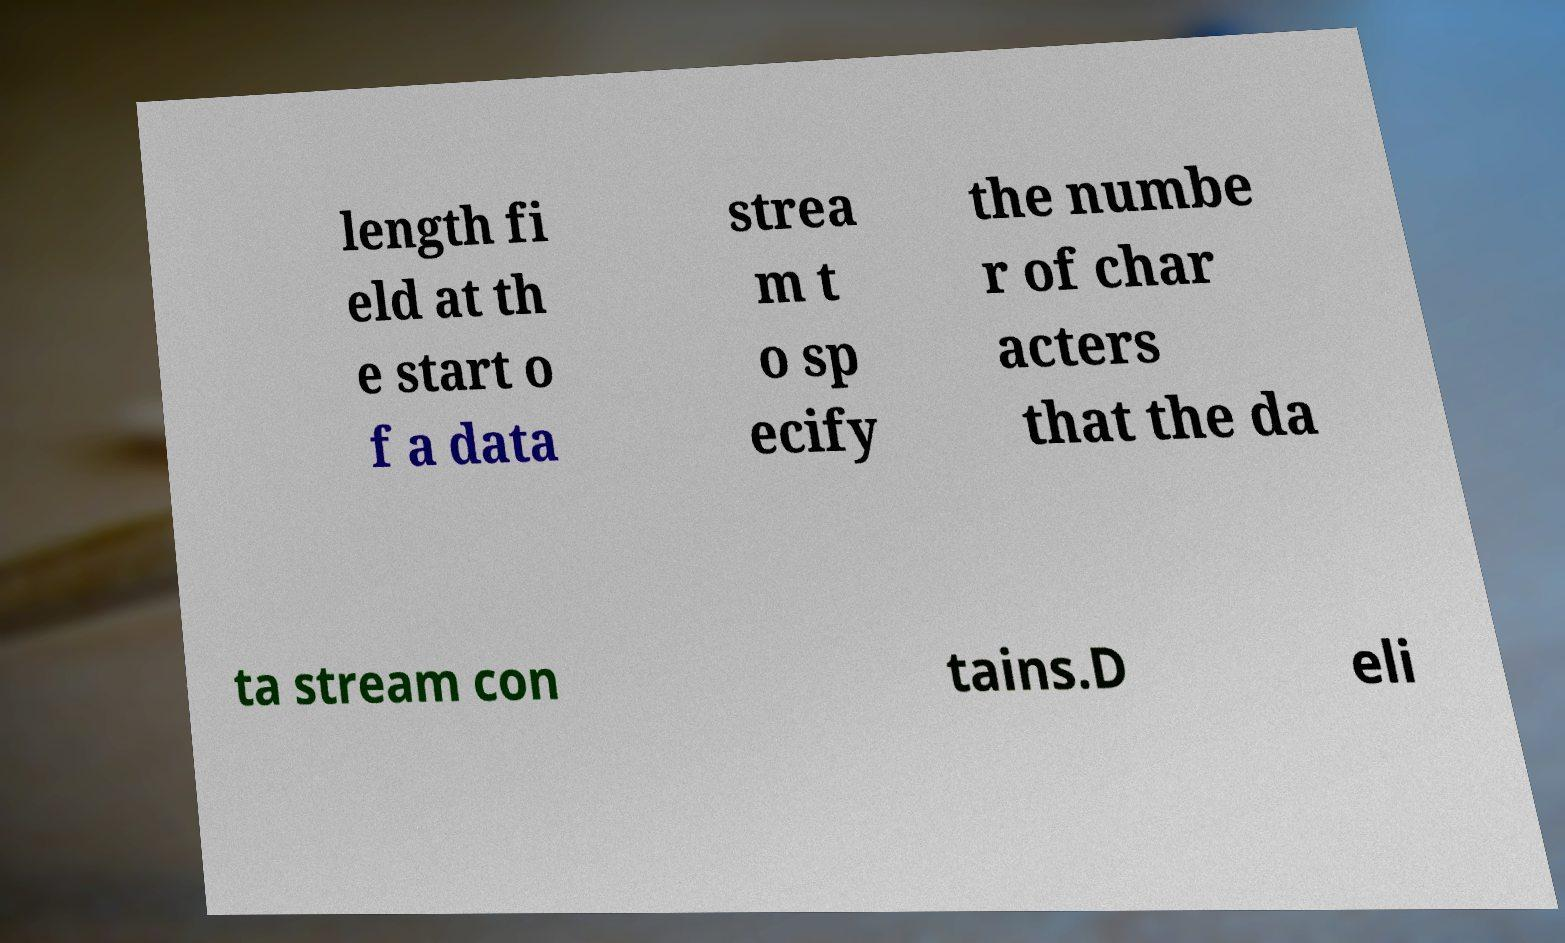Can you accurately transcribe the text from the provided image for me? length fi eld at th e start o f a data strea m t o sp ecify the numbe r of char acters that the da ta stream con tains.D eli 